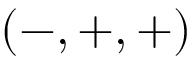<formula> <loc_0><loc_0><loc_500><loc_500>( - , + , + )</formula> 